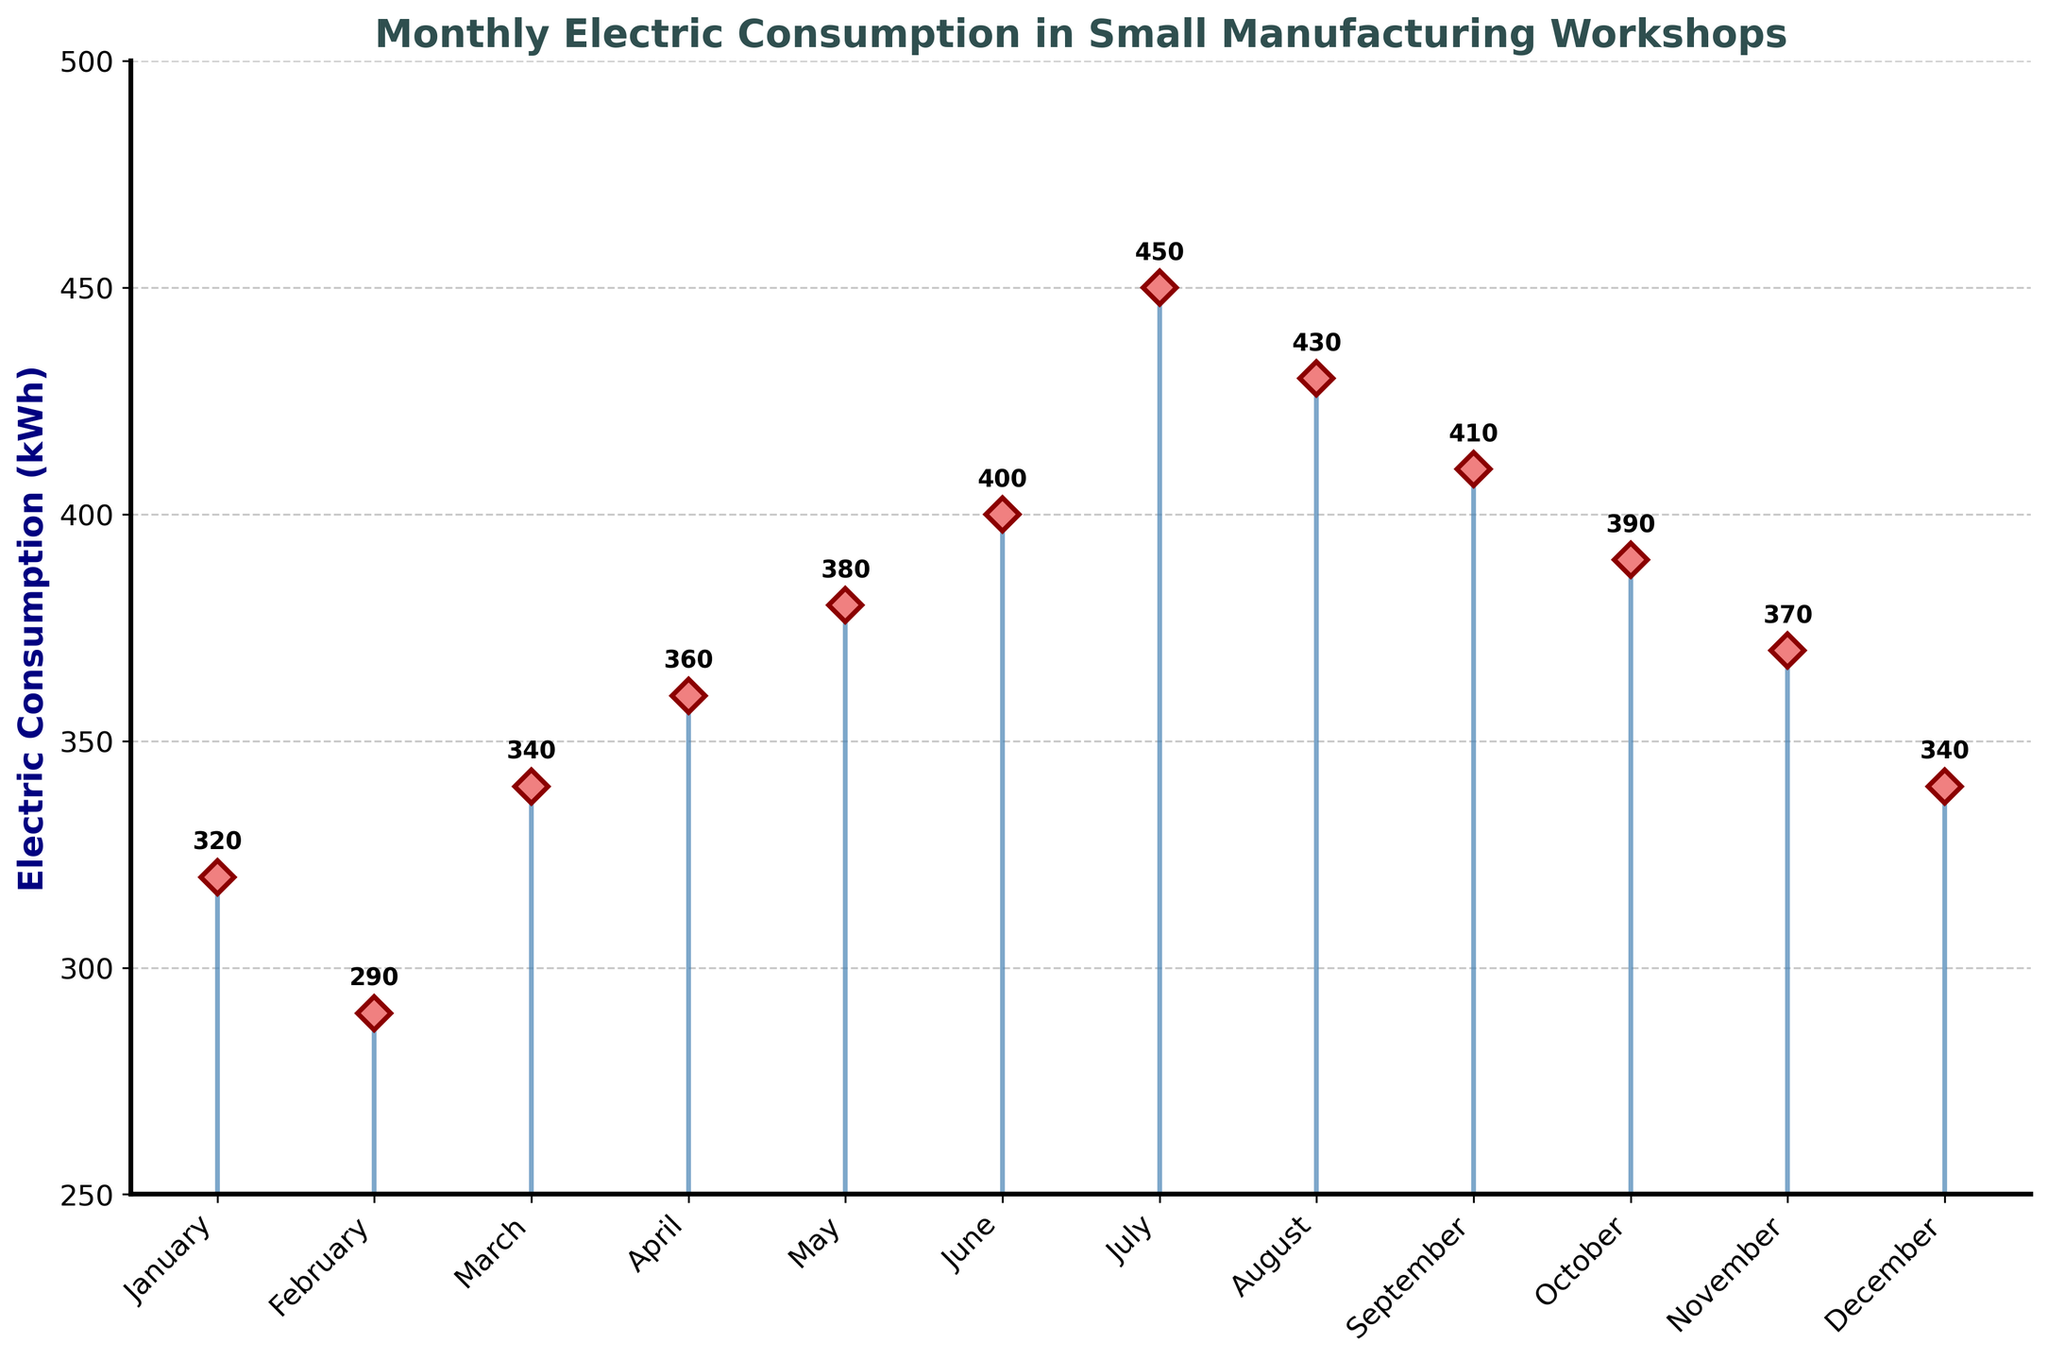what is the title of This figure? Look at the top of the figure, where the title is displayed clearly.
Answer: Monthly Electric Consumption in Small Manufacturing Workshops Which month had the highest electric consumption? Find the highest point on the stem plot and note its corresponding month. The highest point is in July with 450 kWh.
Answer: July What is the electric consumption in February? Look for February on the x-axis and follow the corresponding stem line to the top to read the value. The mark indicates 290 kWh.
Answer: 290 kWh How much did electric consumption increase from January to July? Identify the consumption values for January (320 kWh) and July (450 kWh). Subtract January's value from July's value: 450 - 320 = 130 kWh.
Answer: 130 kWh During which month(s) was electric consumption exactly 340 kWh? Locate the stems exactly at 340 kWh and check their corresponding months on the x-axis.
Answer: March and December What is the average electric consumption from May to August? Identify the consumption values for May (380 kWh), June (400 kWh), July (450 kWh), and August (430 kWh). Add these values: 380 + 400 + 450 + 430 = 1660. Then divide by the number of months: 1660 / 4 = 415 kWh.
Answer: 415 kWh How does the electric consumption in October compare to that in November? Locate the values for October (390 kWh) and November (370 kWh) on the stem plot. Determine if October's value is greater than, less than, or equal to November's value. 390 kWh is greater than 370 kWh.
Answer: October's consumption is higher Which months had a consumption lower than 350 kWh? Locate stems below the 350 kWh mark and identify their corresponding months.
Answer: January, February, and December What trend can you observe in electric consumption from January to August? Observe the general direction of the stems from January to August. Notice if they are increasingly higher or lower overall. Consumption generally increases from January to August.
Answer: Increasing trend Which month had the same electric consumption as March? Identify the consumption value for March (340 kWh) and match the additional month with the same height of the stem. December also had 340 kWh.
Answer: December 